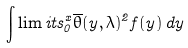<formula> <loc_0><loc_0><loc_500><loc_500>\int \lim i t s _ { 0 } ^ { x } \overline { \theta } ( y , \lambda ) ^ { 2 } f ( y ) \, d y</formula> 